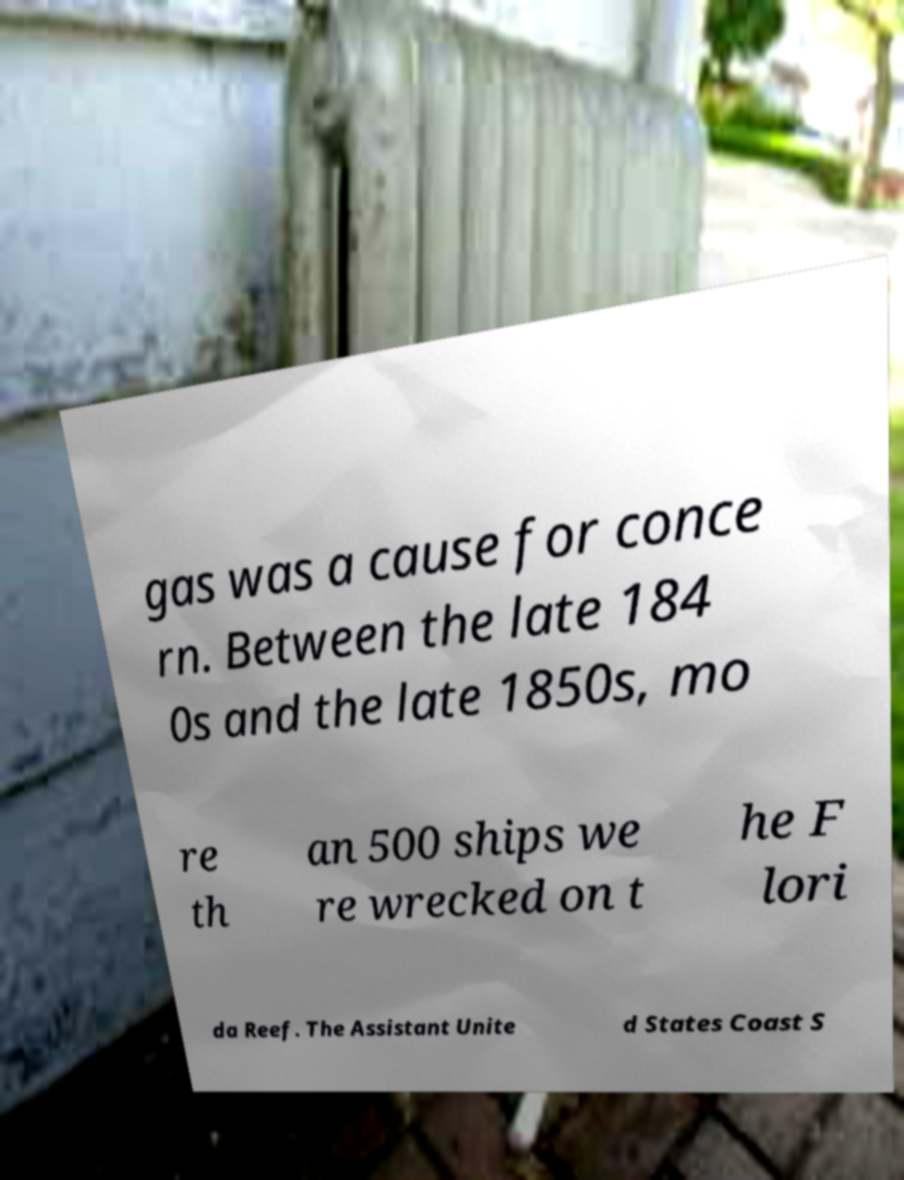There's text embedded in this image that I need extracted. Can you transcribe it verbatim? gas was a cause for conce rn. Between the late 184 0s and the late 1850s, mo re th an 500 ships we re wrecked on t he F lori da Reef. The Assistant Unite d States Coast S 